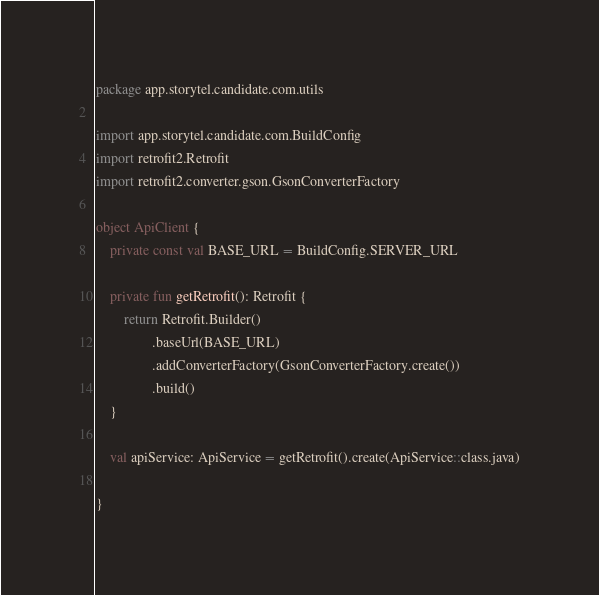<code> <loc_0><loc_0><loc_500><loc_500><_Kotlin_>package app.storytel.candidate.com.utils

import app.storytel.candidate.com.BuildConfig
import retrofit2.Retrofit
import retrofit2.converter.gson.GsonConverterFactory

object ApiClient {
    private const val BASE_URL = BuildConfig.SERVER_URL

    private fun getRetrofit(): Retrofit {
        return Retrofit.Builder()
                .baseUrl(BASE_URL)
                .addConverterFactory(GsonConverterFactory.create())
                .build()
    }

    val apiService: ApiService = getRetrofit().create(ApiService::class.java)

}
</code> 